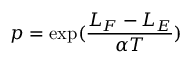Convert formula to latex. <formula><loc_0><loc_0><loc_500><loc_500>p = \exp ( \frac { L _ { F } - L _ { E } } { \alpha T } )</formula> 